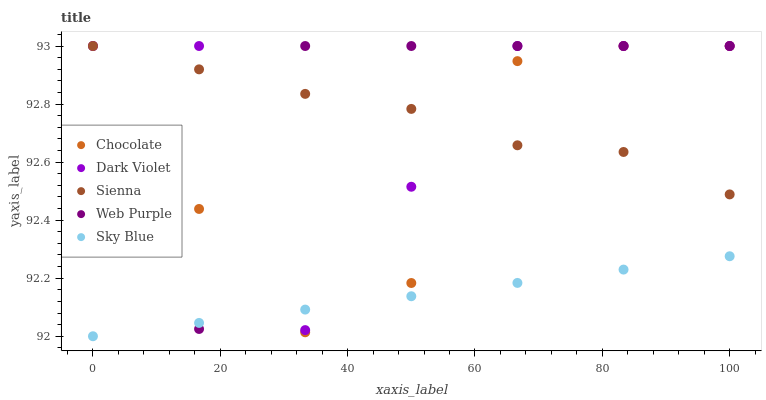Does Sky Blue have the minimum area under the curve?
Answer yes or no. Yes. Does Web Purple have the maximum area under the curve?
Answer yes or no. Yes. Does Web Purple have the minimum area under the curve?
Answer yes or no. No. Does Sky Blue have the maximum area under the curve?
Answer yes or no. No. Is Sky Blue the smoothest?
Answer yes or no. Yes. Is Dark Violet the roughest?
Answer yes or no. Yes. Is Web Purple the smoothest?
Answer yes or no. No. Is Web Purple the roughest?
Answer yes or no. No. Does Sky Blue have the lowest value?
Answer yes or no. Yes. Does Web Purple have the lowest value?
Answer yes or no. No. Does Chocolate have the highest value?
Answer yes or no. Yes. Does Sky Blue have the highest value?
Answer yes or no. No. Is Sky Blue less than Sienna?
Answer yes or no. Yes. Is Sienna greater than Sky Blue?
Answer yes or no. Yes. Does Chocolate intersect Sky Blue?
Answer yes or no. Yes. Is Chocolate less than Sky Blue?
Answer yes or no. No. Is Chocolate greater than Sky Blue?
Answer yes or no. No. Does Sky Blue intersect Sienna?
Answer yes or no. No. 